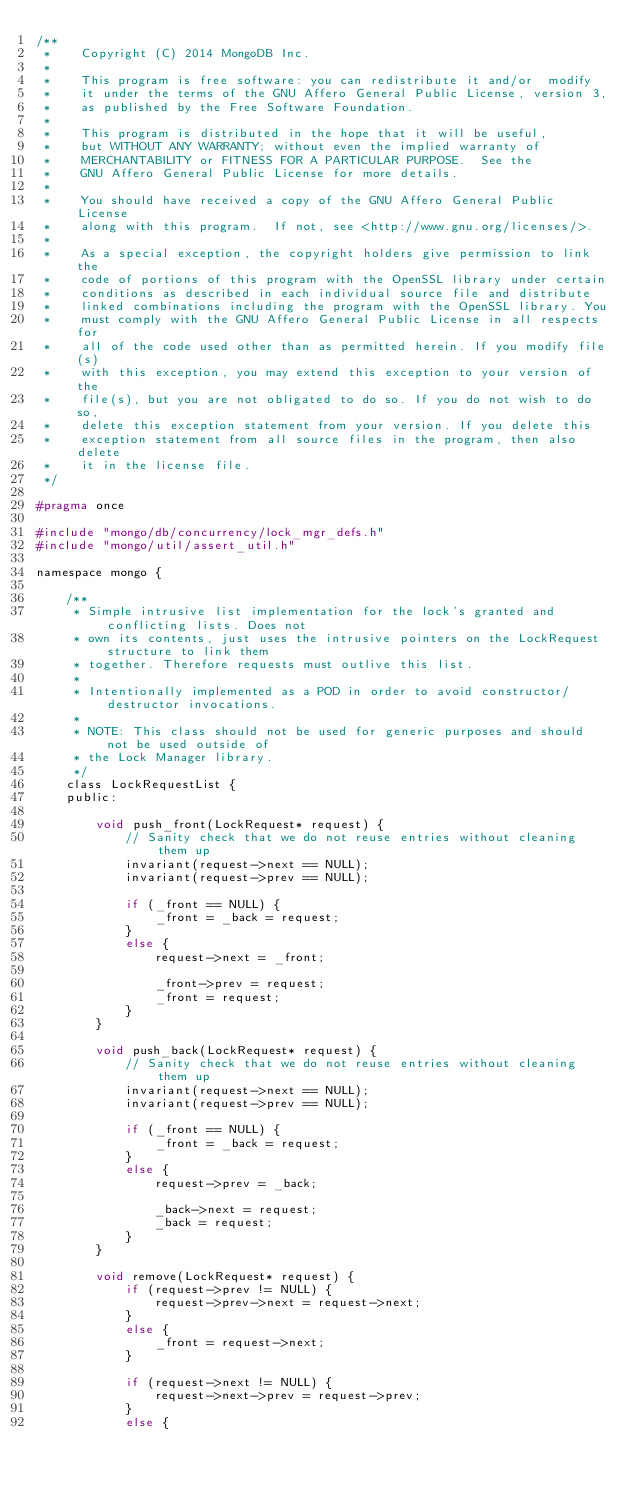Convert code to text. <code><loc_0><loc_0><loc_500><loc_500><_C_>/**
 *    Copyright (C) 2014 MongoDB Inc.
 *
 *    This program is free software: you can redistribute it and/or  modify
 *    it under the terms of the GNU Affero General Public License, version 3,
 *    as published by the Free Software Foundation.
 *
 *    This program is distributed in the hope that it will be useful,
 *    but WITHOUT ANY WARRANTY; without even the implied warranty of
 *    MERCHANTABILITY or FITNESS FOR A PARTICULAR PURPOSE.  See the
 *    GNU Affero General Public License for more details.
 *
 *    You should have received a copy of the GNU Affero General Public License
 *    along with this program.  If not, see <http://www.gnu.org/licenses/>.
 *
 *    As a special exception, the copyright holders give permission to link the
 *    code of portions of this program with the OpenSSL library under certain
 *    conditions as described in each individual source file and distribute
 *    linked combinations including the program with the OpenSSL library. You
 *    must comply with the GNU Affero General Public License in all respects for
 *    all of the code used other than as permitted herein. If you modify file(s)
 *    with this exception, you may extend this exception to your version of the
 *    file(s), but you are not obligated to do so. If you do not wish to do so,
 *    delete this exception statement from your version. If you delete this
 *    exception statement from all source files in the program, then also delete
 *    it in the license file.
 */

#pragma once

#include "mongo/db/concurrency/lock_mgr_defs.h"
#include "mongo/util/assert_util.h"

namespace mongo {

    /**
     * Simple intrusive list implementation for the lock's granted and conflicting lists. Does not
     * own its contents, just uses the intrusive pointers on the LockRequest structure to link them
     * together. Therefore requests must outlive this list.
     *
     * Intentionally implemented as a POD in order to avoid constructor/destructor invocations.
     *
     * NOTE: This class should not be used for generic purposes and should not be used outside of
     * the Lock Manager library.
     */
    class LockRequestList {
    public:

        void push_front(LockRequest* request) {
            // Sanity check that we do not reuse entries without cleaning them up
            invariant(request->next == NULL);
            invariant(request->prev == NULL);

            if (_front == NULL) {
                _front = _back = request;
            }
            else {
                request->next = _front;

                _front->prev = request;
                _front = request;
            }
        }

        void push_back(LockRequest* request) {
            // Sanity check that we do not reuse entries without cleaning them up
            invariant(request->next == NULL);
            invariant(request->prev == NULL);

            if (_front == NULL) {
                _front = _back = request;
            }
            else {
                request->prev = _back;

                _back->next = request;
                _back = request;
            }
        }

        void remove(LockRequest* request) {
            if (request->prev != NULL) {
                request->prev->next = request->next;
            }
            else {
                _front = request->next;
            }

            if (request->next != NULL) {
                request->next->prev = request->prev;
            }
            else {</code> 